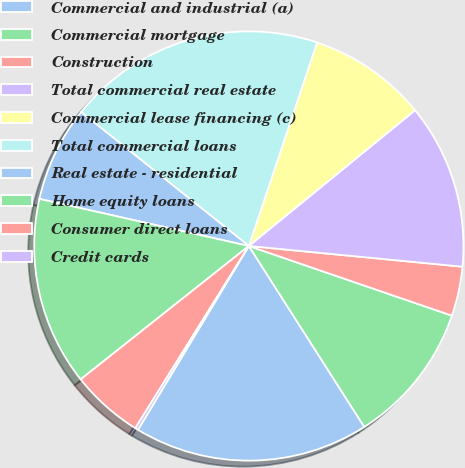Convert chart. <chart><loc_0><loc_0><loc_500><loc_500><pie_chart><fcel>Commercial and industrial (a)<fcel>Commercial mortgage<fcel>Construction<fcel>Total commercial real estate<fcel>Commercial lease financing (c)<fcel>Total commercial loans<fcel>Real estate - residential<fcel>Home equity loans<fcel>Consumer direct loans<fcel>Credit cards<nl><fcel>17.68%<fcel>10.7%<fcel>3.72%<fcel>12.44%<fcel>8.95%<fcel>19.42%<fcel>7.21%<fcel>14.19%<fcel>5.46%<fcel>0.23%<nl></chart> 